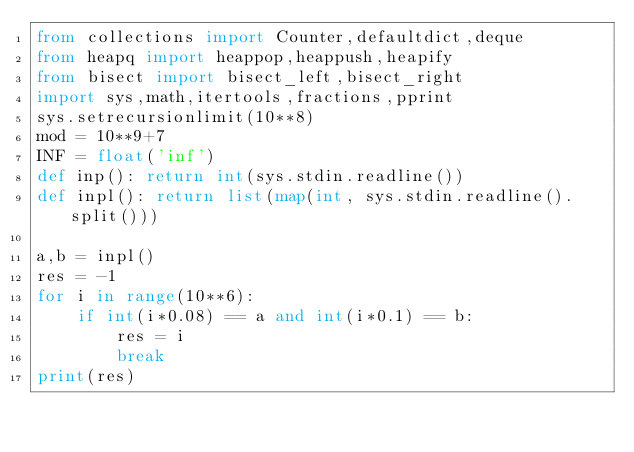Convert code to text. <code><loc_0><loc_0><loc_500><loc_500><_Python_>from collections import Counter,defaultdict,deque
from heapq import heappop,heappush,heapify
from bisect import bisect_left,bisect_right 
import sys,math,itertools,fractions,pprint
sys.setrecursionlimit(10**8)
mod = 10**9+7
INF = float('inf')
def inp(): return int(sys.stdin.readline())
def inpl(): return list(map(int, sys.stdin.readline().split()))

a,b = inpl()
res = -1
for i in range(10**6):
    if int(i*0.08) == a and int(i*0.1) == b:
        res = i
        break
print(res)</code> 